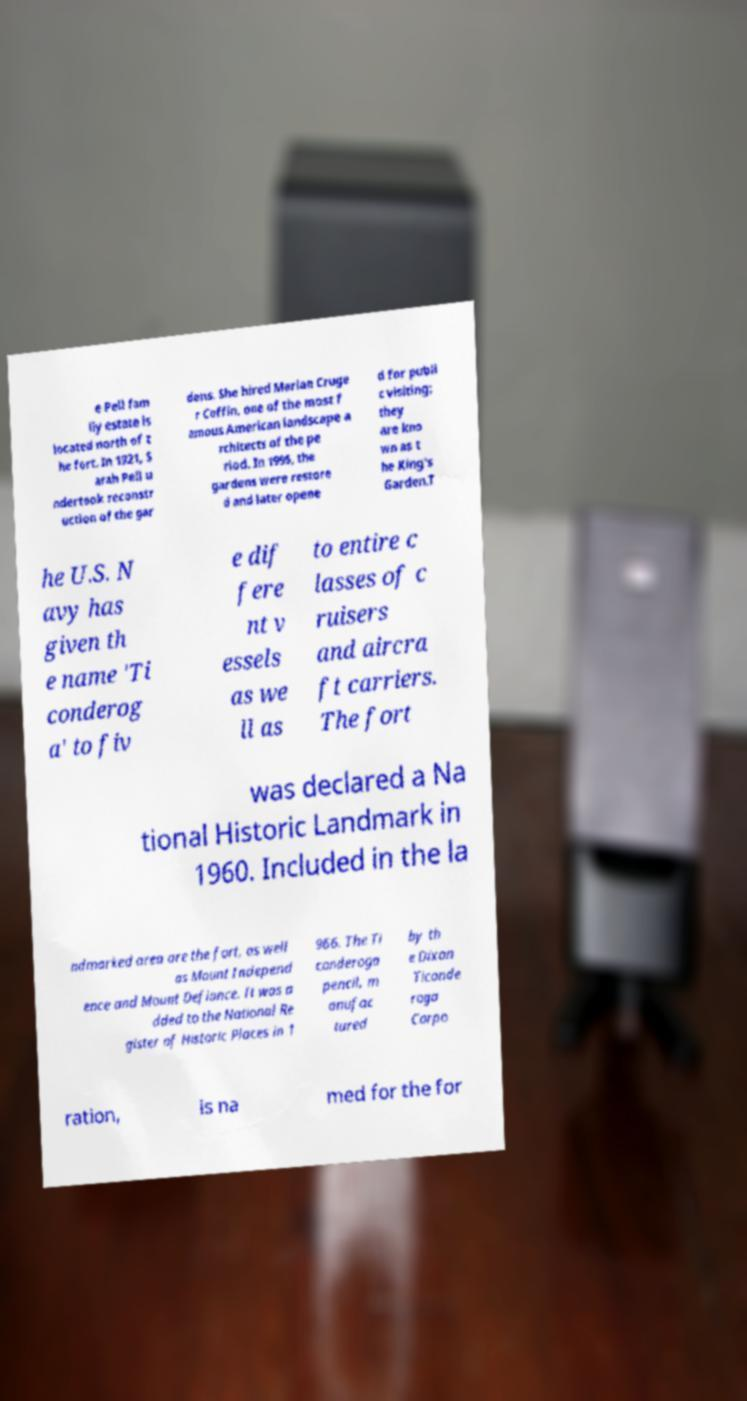I need the written content from this picture converted into text. Can you do that? e Pell fam ily estate is located north of t he fort. In 1921, S arah Pell u ndertook reconstr uction of the gar dens. She hired Marian Cruge r Coffin, one of the most f amous American landscape a rchitects of the pe riod. In 1995, the gardens were restore d and later opene d for publi c visiting; they are kno wn as t he King's Garden.T he U.S. N avy has given th e name 'Ti conderog a' to fiv e dif fere nt v essels as we ll as to entire c lasses of c ruisers and aircra ft carriers. The fort was declared a Na tional Historic Landmark in 1960. Included in the la ndmarked area are the fort, as well as Mount Independ ence and Mount Defiance. It was a dded to the National Re gister of Historic Places in 1 966. The Ti conderoga pencil, m anufac tured by th e Dixon Ticonde roga Corpo ration, is na med for the for 